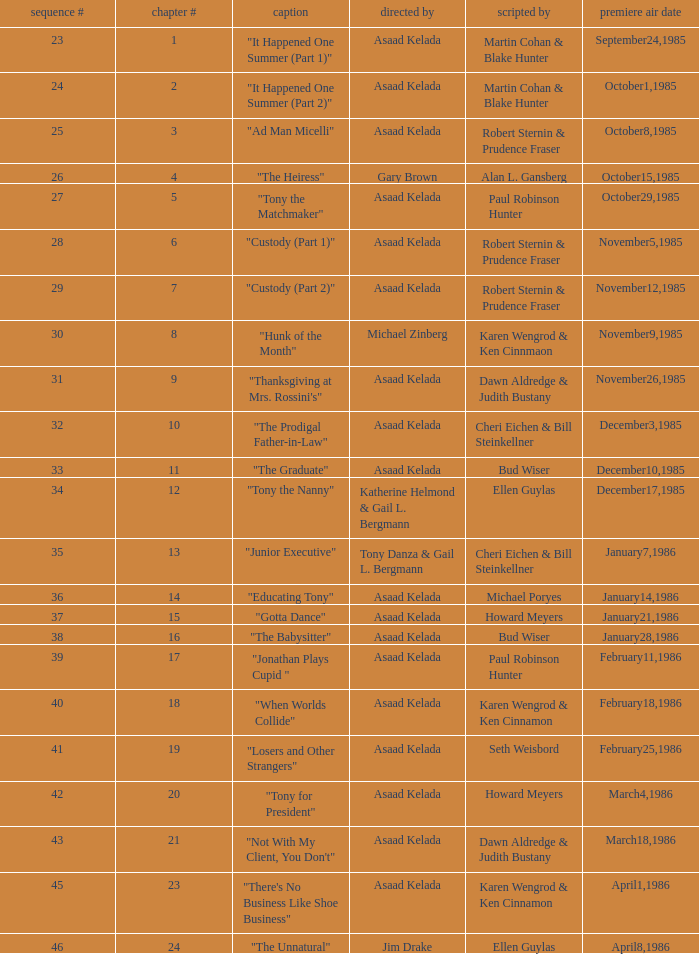Would you be able to parse every entry in this table? {'header': ['sequence #', 'chapter #', 'caption', 'directed by', 'scripted by', 'premiere air date'], 'rows': [['23', '1', '"It Happened One Summer (Part 1)"', 'Asaad Kelada', 'Martin Cohan & Blake Hunter', 'September24,1985'], ['24', '2', '"It Happened One Summer (Part 2)"', 'Asaad Kelada', 'Martin Cohan & Blake Hunter', 'October1,1985'], ['25', '3', '"Ad Man Micelli"', 'Asaad Kelada', 'Robert Sternin & Prudence Fraser', 'October8,1985'], ['26', '4', '"The Heiress"', 'Gary Brown', 'Alan L. Gansberg', 'October15,1985'], ['27', '5', '"Tony the Matchmaker"', 'Asaad Kelada', 'Paul Robinson Hunter', 'October29,1985'], ['28', '6', '"Custody (Part 1)"', 'Asaad Kelada', 'Robert Sternin & Prudence Fraser', 'November5,1985'], ['29', '7', '"Custody (Part 2)"', 'Asaad Kelada', 'Robert Sternin & Prudence Fraser', 'November12,1985'], ['30', '8', '"Hunk of the Month"', 'Michael Zinberg', 'Karen Wengrod & Ken Cinnmaon', 'November9,1985'], ['31', '9', '"Thanksgiving at Mrs. Rossini\'s"', 'Asaad Kelada', 'Dawn Aldredge & Judith Bustany', 'November26,1985'], ['32', '10', '"The Prodigal Father-in-Law"', 'Asaad Kelada', 'Cheri Eichen & Bill Steinkellner', 'December3,1985'], ['33', '11', '"The Graduate"', 'Asaad Kelada', 'Bud Wiser', 'December10,1985'], ['34', '12', '"Tony the Nanny"', 'Katherine Helmond & Gail L. Bergmann', 'Ellen Guylas', 'December17,1985'], ['35', '13', '"Junior Executive"', 'Tony Danza & Gail L. Bergmann', 'Cheri Eichen & Bill Steinkellner', 'January7,1986'], ['36', '14', '"Educating Tony"', 'Asaad Kelada', 'Michael Poryes', 'January14,1986'], ['37', '15', '"Gotta Dance"', 'Asaad Kelada', 'Howard Meyers', 'January21,1986'], ['38', '16', '"The Babysitter"', 'Asaad Kelada', 'Bud Wiser', 'January28,1986'], ['39', '17', '"Jonathan Plays Cupid "', 'Asaad Kelada', 'Paul Robinson Hunter', 'February11,1986'], ['40', '18', '"When Worlds Collide"', 'Asaad Kelada', 'Karen Wengrod & Ken Cinnamon', 'February18,1986'], ['41', '19', '"Losers and Other Strangers"', 'Asaad Kelada', 'Seth Weisbord', 'February25,1986'], ['42', '20', '"Tony for President"', 'Asaad Kelada', 'Howard Meyers', 'March4,1986'], ['43', '21', '"Not With My Client, You Don\'t"', 'Asaad Kelada', 'Dawn Aldredge & Judith Bustany', 'March18,1986'], ['45', '23', '"There\'s No Business Like Shoe Business"', 'Asaad Kelada', 'Karen Wengrod & Ken Cinnamon', 'April1,1986'], ['46', '24', '"The Unnatural"', 'Jim Drake', 'Ellen Guylas', 'April8,1986']]} What is the season where the episode "when worlds collide" was shown? 18.0. 